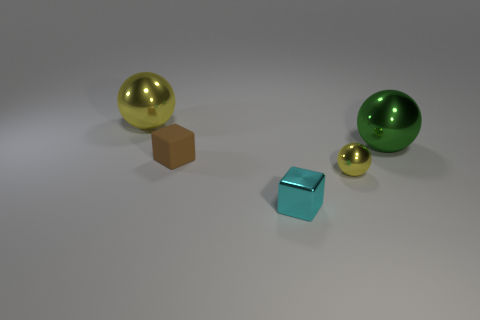There is a thing that is in front of the big green metallic thing and behind the small metallic ball; what size is it?
Your answer should be compact. Small. There is another sphere that is the same color as the tiny metallic sphere; what is its size?
Your response must be concise. Large. What is the color of the thing that is on the right side of the yellow metallic sphere in front of the big metallic object left of the cyan metal object?
Keep it short and to the point. Green. What is the color of the other cube that is the same size as the cyan cube?
Your response must be concise. Brown. What shape is the shiny object in front of the yellow shiny thing that is right of the sphere that is on the left side of the cyan metal object?
Give a very brief answer. Cube. What is the shape of the thing that is the same color as the tiny sphere?
Keep it short and to the point. Sphere. What number of objects are either tiny brown metallic objects or big spheres that are behind the small matte cube?
Your answer should be compact. 2. Does the metal object behind the green object have the same size as the small shiny ball?
Give a very brief answer. No. There is a large object to the left of the small cyan object; what is it made of?
Give a very brief answer. Metal. Is the number of metallic cubes that are in front of the brown rubber thing the same as the number of yellow things on the right side of the cyan thing?
Offer a terse response. Yes. 